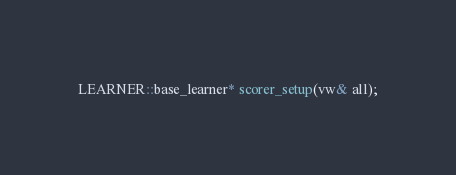Convert code to text. <code><loc_0><loc_0><loc_500><loc_500><_C_>LEARNER::base_learner* scorer_setup(vw& all);
</code> 